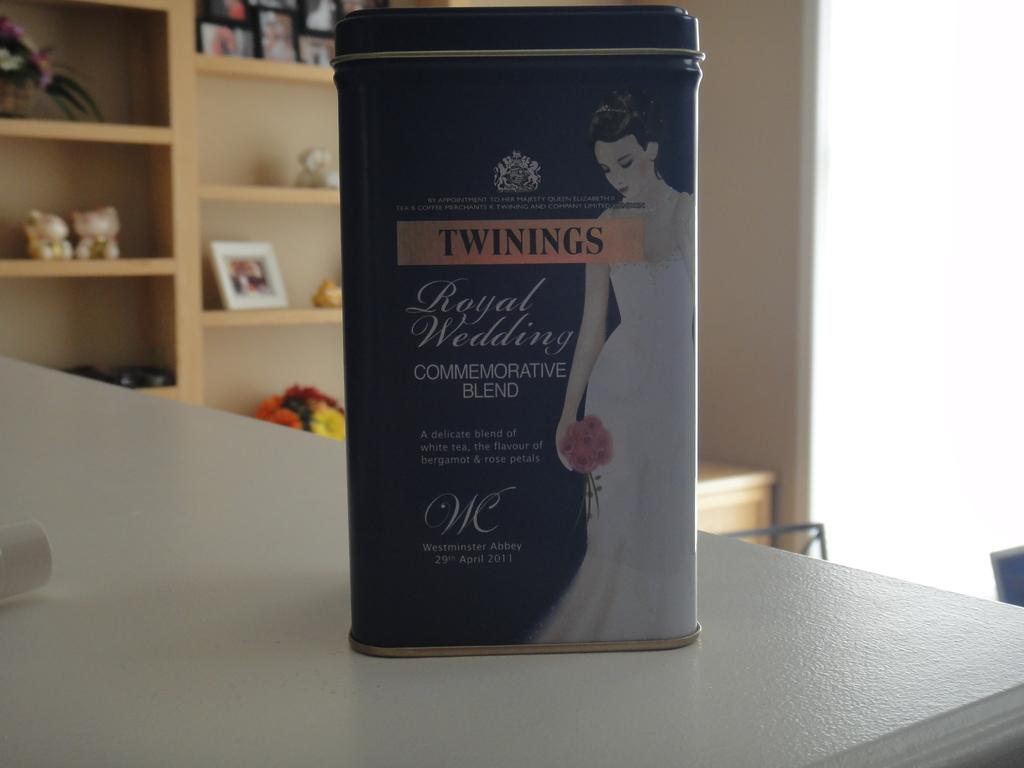<image>
Write a terse but informative summary of the picture. A cannister of Twinings tea with an image of a woman on it. 